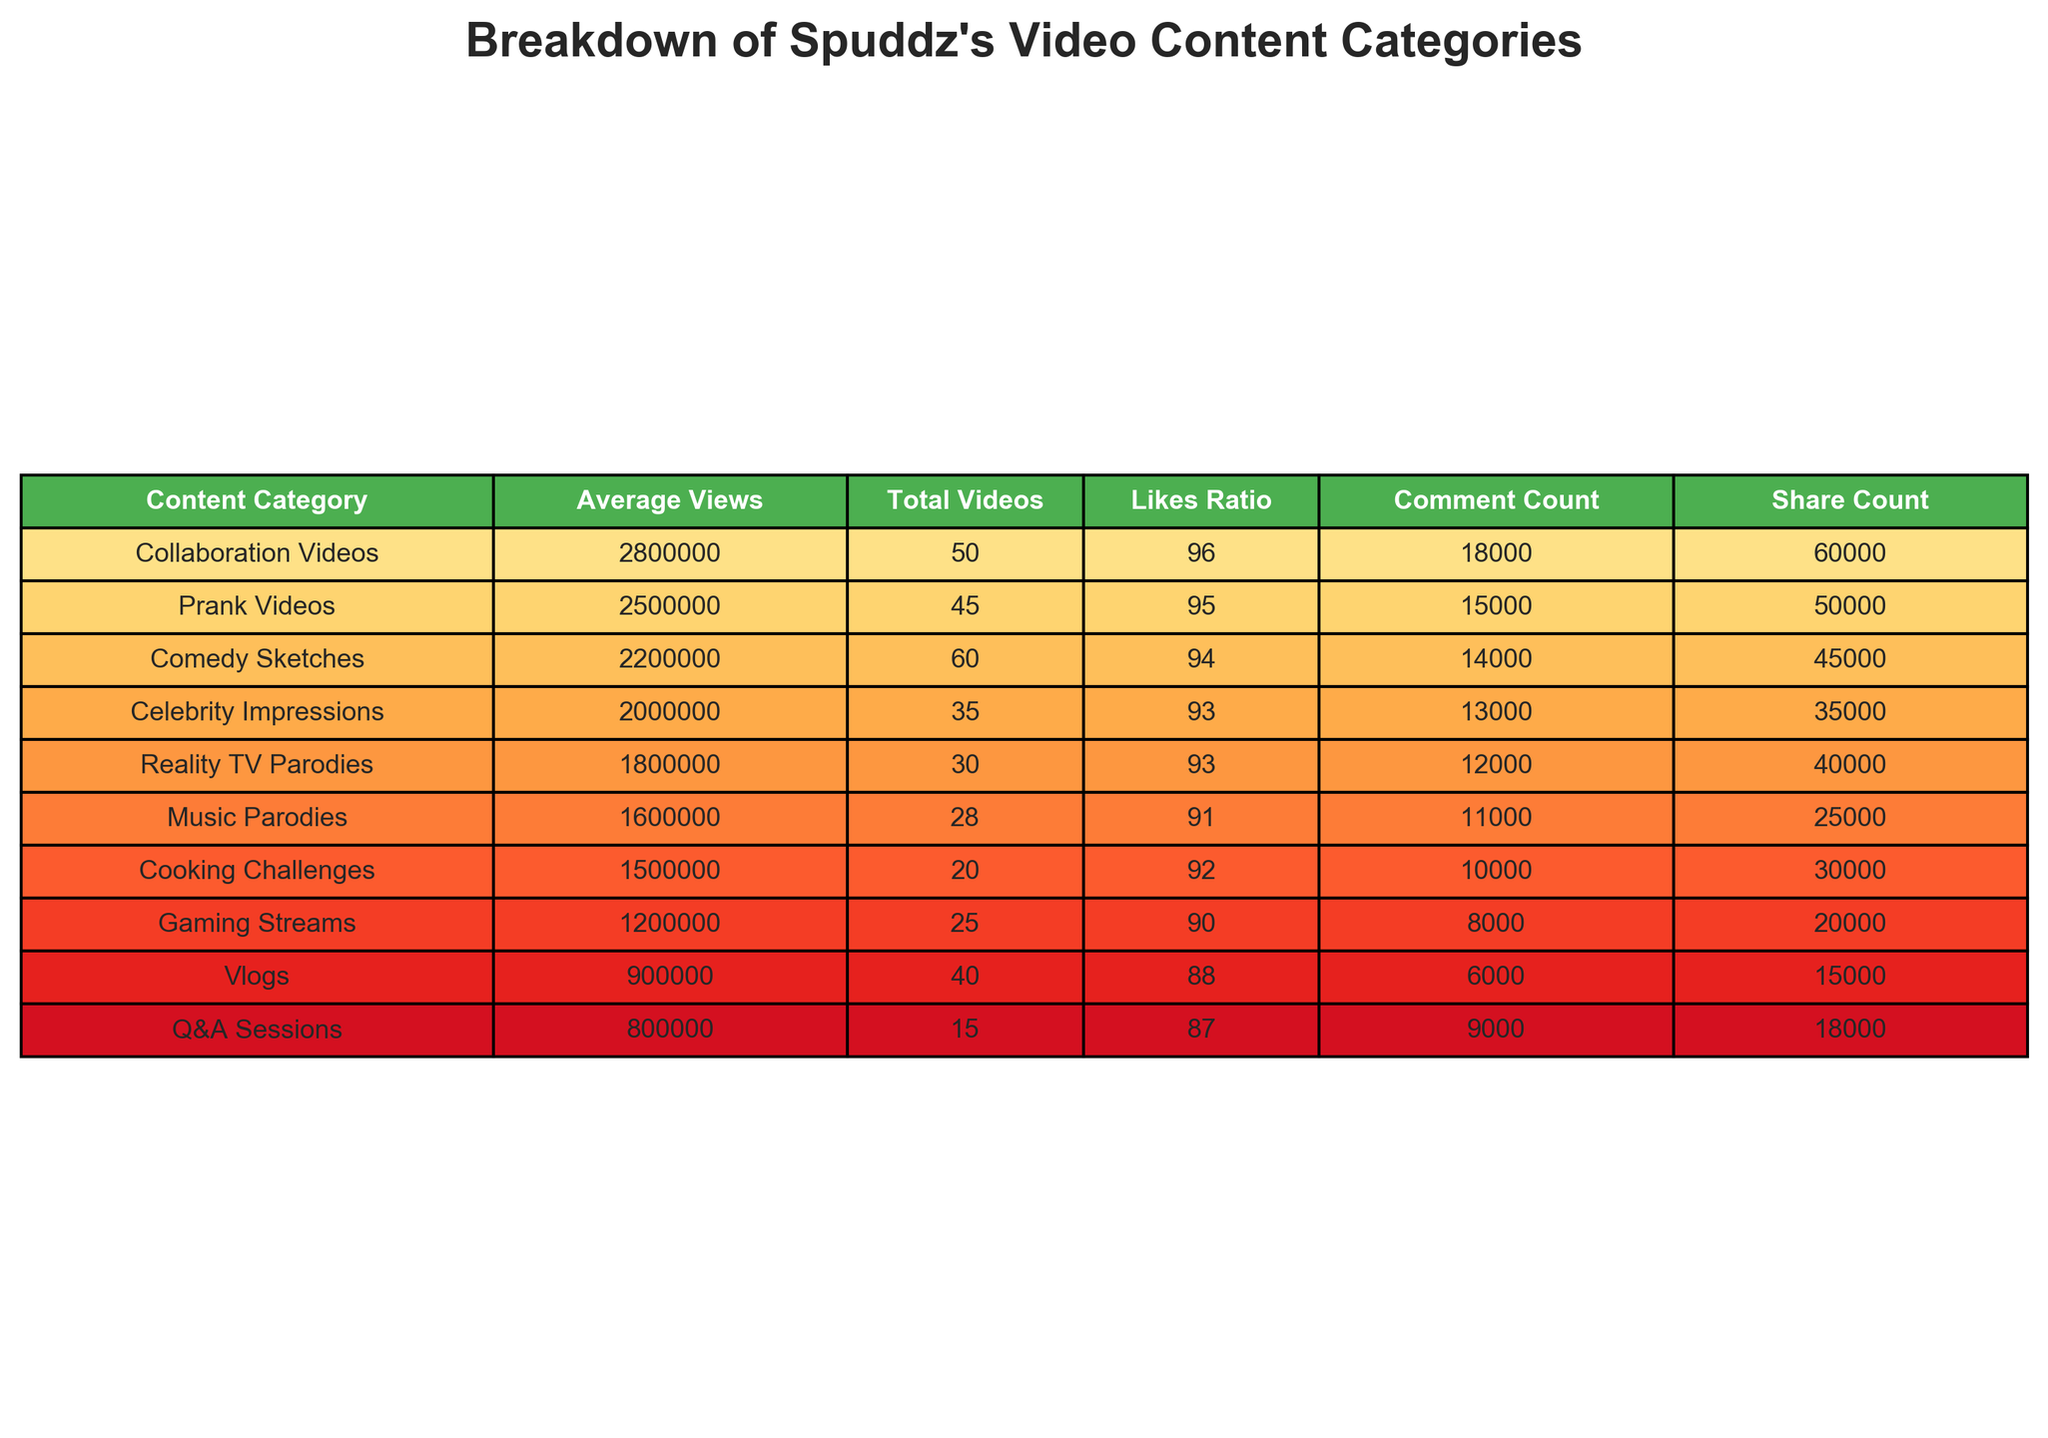What is the content category with the highest average views? By examining the table, we see that "Collaboration Videos" has the highest average views at 2,800,000.
Answer: Collaboration Videos How many total videos does Spuddz have in Prank Videos? The table lists the "Total Videos" for "Prank Videos" as 45.
Answer: 45 What is the likes ratio for Cooking Challenges? The table shows that the likes ratio for "Cooking Challenges" is 92%.
Answer: 92% Which video content category has the lowest average views? "Q&A Sessions" has the lowest average views at 800,000, as observed in the average views column.
Answer: Q&A Sessions Calculate the average views of all the content categories listed. To find the average views, sum all average views: (2500000 + 1800000 + 2200000 + 1200000 + 900000 + 1500000 + 2000000 + 800000 + 2800000 + 1600000) = 14,900,000. There are 10 categories, so the average is 14,900,000 / 10 = 1,490,000.
Answer: 1,490,000 Is the likes ratio for Gaming Streams above or below 90%? The table provides a likes ratio of 90% for "Gaming Streams," so it is exactly at 90% and therefore not above.
Answer: No What is the difference in average views between Comedy Sketches and Vlogs? From the table, "Comedy Sketches" averages 2,200,000 views and "Vlogs" averages 900,000 views. The difference is 2,200,000 - 900,000 = 1,300,000.
Answer: 1,300,000 Which content category has more shares: Reality TV Parodies or Music Parodies? According to the table, "Reality TV Parodies" has 40,000 shares while "Music Parodies" has 25,000 shares. Therefore, Reality TV Parodies has more shares.
Answer: Reality TV Parodies How many likes are there on average for the top three categories by average views? The top three categories by average views are "Collaboration Videos" (2,800,000), "Prank Videos" (2,500,000), and "Celebrity Impressions" (2,000,000). The total is 2,800,000 + 2,500,000 + 2,000,000 = 7,300,000. Dividing by three gives an average of 7,300,000 / 3 = 2,433,333.33.
Answer: 2,433,333.33 Are there more total videos in the categories with average views over 1,500,000 than those below? The categories over 1,500,000 are "Collaboration Videos" (50), "Prank Videos" (45), "Comedy Sketches" (60), "Celebrity Impressions" (35), and "Music Parodies" (28) totaling 218. The categories below are "Reality TV Parodies" (30), "Gaming Streams" (25), "Vlogs" (40), "Cooking Challenges" (20), and "Q&A Sessions" (15) totaling 130. Since 218 > 130, the answer is yes.
Answer: Yes 